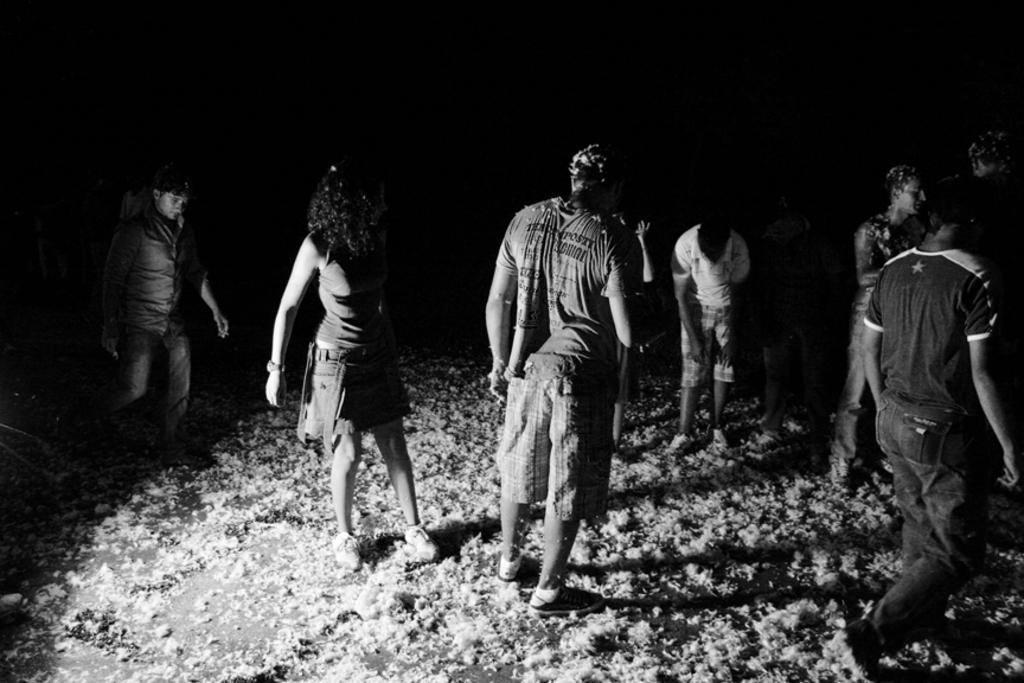What is the color scheme of the image? The image is black and white. What can be seen in the center of the image? There are people standing in the center of the image. What else is present in the image besides the people? There are other objects present in the image. What type of design can be seen on the office desk in the image? There is no office desk or any reference to an office in the image. 